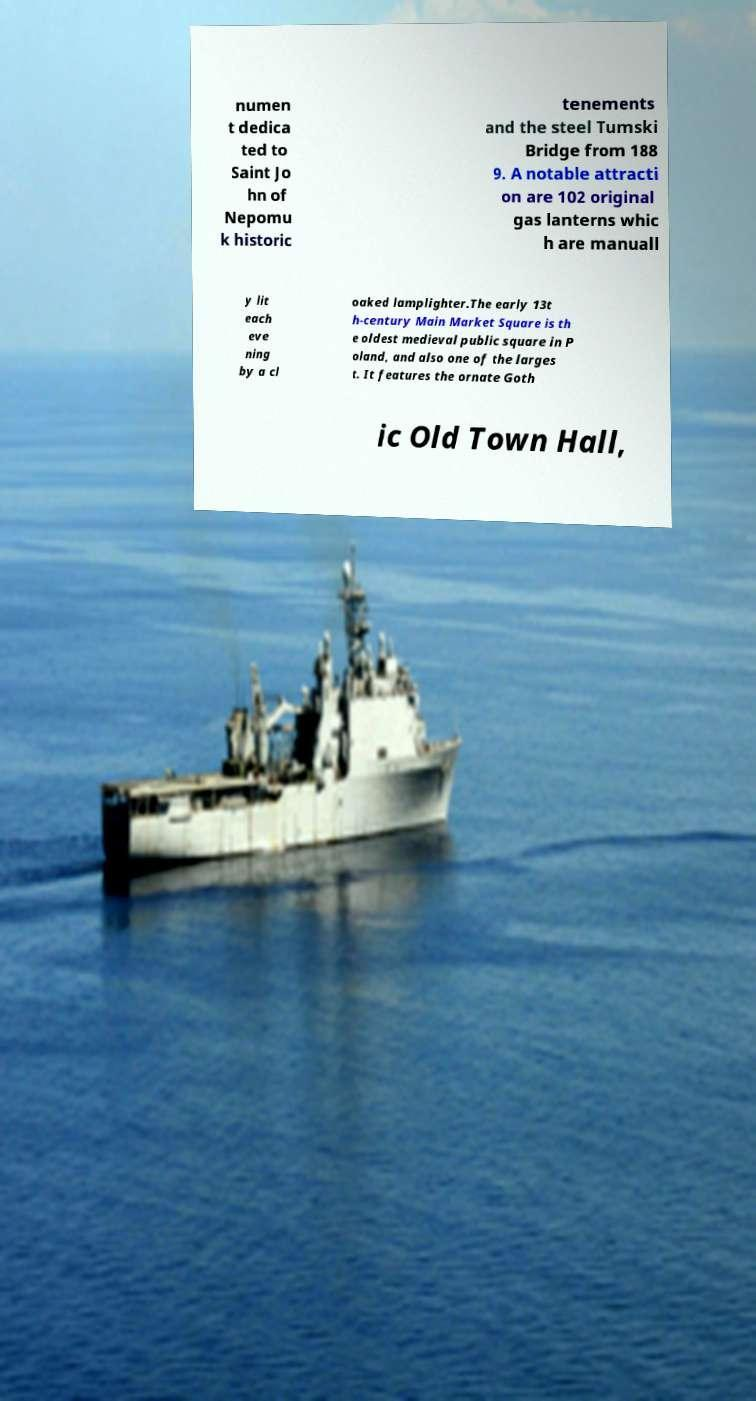For documentation purposes, I need the text within this image transcribed. Could you provide that? numen t dedica ted to Saint Jo hn of Nepomu k historic tenements and the steel Tumski Bridge from 188 9. A notable attracti on are 102 original gas lanterns whic h are manuall y lit each eve ning by a cl oaked lamplighter.The early 13t h-century Main Market Square is th e oldest medieval public square in P oland, and also one of the larges t. It features the ornate Goth ic Old Town Hall, 